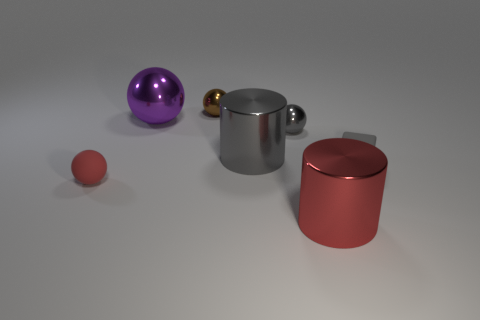What is the material of the small red sphere?
Give a very brief answer. Rubber. What material is the brown sphere that is the same size as the red matte thing?
Your answer should be compact. Metal. Is there a matte sphere of the same size as the brown metal thing?
Your answer should be compact. Yes. Are there the same number of small gray rubber objects that are in front of the small red rubber thing and big red cylinders in front of the purple shiny thing?
Provide a short and direct response. No. Are there more tiny gray rubber things than large cylinders?
Provide a succinct answer. No. How many metallic things are blue cylinders or tiny gray spheres?
Provide a short and direct response. 1. How many small metal objects have the same color as the small block?
Your answer should be very brief. 1. What is the material of the red object on the left side of the tiny metal thing that is in front of the large purple shiny thing to the right of the tiny red object?
Provide a short and direct response. Rubber. What is the color of the big thing left of the metallic sphere behind the purple thing?
Your response must be concise. Purple. How many tiny things are either brown matte blocks or purple objects?
Ensure brevity in your answer.  0. 